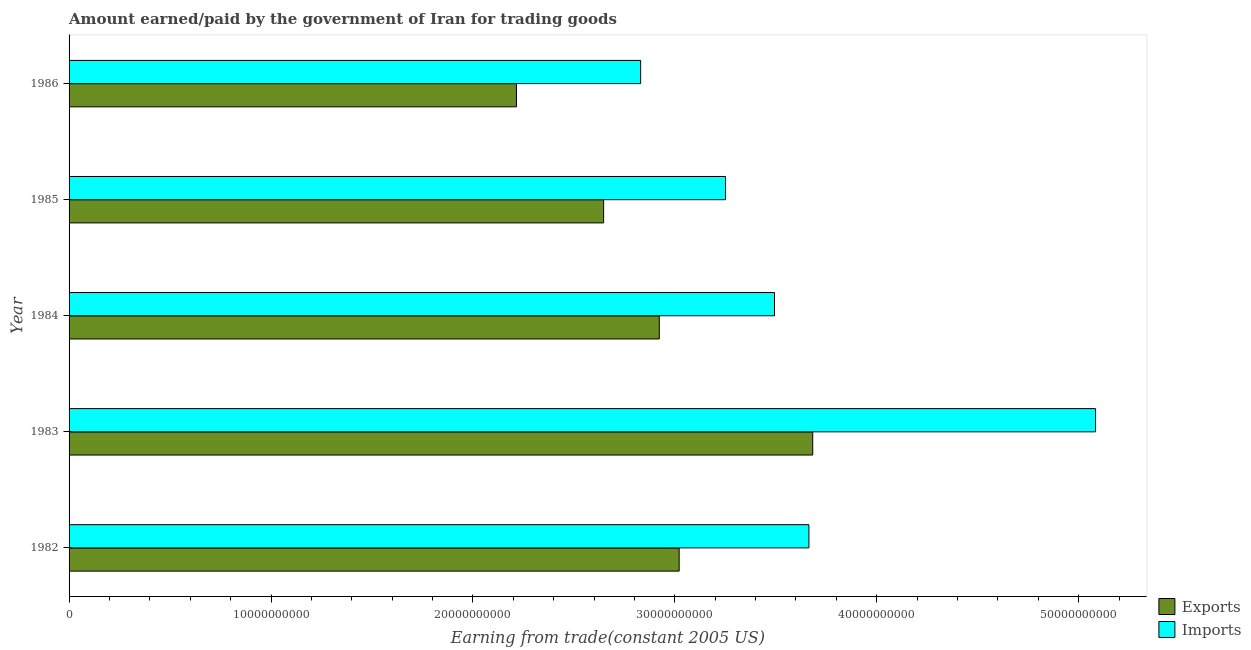How many groups of bars are there?
Make the answer very short. 5. Are the number of bars on each tick of the Y-axis equal?
Ensure brevity in your answer.  Yes. How many bars are there on the 5th tick from the top?
Ensure brevity in your answer.  2. What is the label of the 1st group of bars from the top?
Provide a short and direct response. 1986. In how many cases, is the number of bars for a given year not equal to the number of legend labels?
Provide a short and direct response. 0. What is the amount earned from exports in 1986?
Provide a short and direct response. 2.22e+1. Across all years, what is the maximum amount paid for imports?
Your answer should be compact. 5.08e+1. Across all years, what is the minimum amount paid for imports?
Give a very brief answer. 2.83e+1. In which year was the amount paid for imports minimum?
Provide a succinct answer. 1986. What is the total amount paid for imports in the graph?
Make the answer very short. 1.83e+11. What is the difference between the amount earned from exports in 1983 and that in 1984?
Make the answer very short. 7.60e+09. What is the difference between the amount earned from exports in 1986 and the amount paid for imports in 1982?
Your answer should be compact. -1.45e+1. What is the average amount paid for imports per year?
Give a very brief answer. 3.66e+1. In the year 1982, what is the difference between the amount paid for imports and amount earned from exports?
Your answer should be compact. 6.42e+09. What is the ratio of the amount earned from exports in 1983 to that in 1986?
Your answer should be compact. 1.66. Is the difference between the amount paid for imports in 1984 and 1986 greater than the difference between the amount earned from exports in 1984 and 1986?
Offer a very short reply. No. What is the difference between the highest and the second highest amount paid for imports?
Make the answer very short. 1.42e+1. What is the difference between the highest and the lowest amount earned from exports?
Offer a very short reply. 1.47e+1. In how many years, is the amount paid for imports greater than the average amount paid for imports taken over all years?
Provide a succinct answer. 1. What does the 2nd bar from the top in 1986 represents?
Provide a succinct answer. Exports. What does the 2nd bar from the bottom in 1985 represents?
Provide a succinct answer. Imports. Are all the bars in the graph horizontal?
Your answer should be compact. Yes. How many years are there in the graph?
Provide a short and direct response. 5. What is the difference between two consecutive major ticks on the X-axis?
Your answer should be very brief. 1.00e+1. Are the values on the major ticks of X-axis written in scientific E-notation?
Ensure brevity in your answer.  No. Does the graph contain any zero values?
Give a very brief answer. No. Does the graph contain grids?
Offer a terse response. No. What is the title of the graph?
Your answer should be compact. Amount earned/paid by the government of Iran for trading goods. Does "Public funds" appear as one of the legend labels in the graph?
Ensure brevity in your answer.  No. What is the label or title of the X-axis?
Your answer should be compact. Earning from trade(constant 2005 US). What is the label or title of the Y-axis?
Provide a succinct answer. Year. What is the Earning from trade(constant 2005 US) in Exports in 1982?
Your response must be concise. 3.02e+1. What is the Earning from trade(constant 2005 US) in Imports in 1982?
Your answer should be very brief. 3.66e+1. What is the Earning from trade(constant 2005 US) of Exports in 1983?
Provide a short and direct response. 3.68e+1. What is the Earning from trade(constant 2005 US) of Imports in 1983?
Provide a succinct answer. 5.08e+1. What is the Earning from trade(constant 2005 US) of Exports in 1984?
Provide a succinct answer. 2.92e+1. What is the Earning from trade(constant 2005 US) in Imports in 1984?
Give a very brief answer. 3.49e+1. What is the Earning from trade(constant 2005 US) in Exports in 1985?
Your answer should be compact. 2.65e+1. What is the Earning from trade(constant 2005 US) of Imports in 1985?
Keep it short and to the point. 3.25e+1. What is the Earning from trade(constant 2005 US) of Exports in 1986?
Your answer should be very brief. 2.22e+1. What is the Earning from trade(constant 2005 US) in Imports in 1986?
Your answer should be compact. 2.83e+1. Across all years, what is the maximum Earning from trade(constant 2005 US) of Exports?
Your answer should be compact. 3.68e+1. Across all years, what is the maximum Earning from trade(constant 2005 US) of Imports?
Your response must be concise. 5.08e+1. Across all years, what is the minimum Earning from trade(constant 2005 US) in Exports?
Your response must be concise. 2.22e+1. Across all years, what is the minimum Earning from trade(constant 2005 US) in Imports?
Your answer should be compact. 2.83e+1. What is the total Earning from trade(constant 2005 US) in Exports in the graph?
Make the answer very short. 1.45e+11. What is the total Earning from trade(constant 2005 US) of Imports in the graph?
Make the answer very short. 1.83e+11. What is the difference between the Earning from trade(constant 2005 US) of Exports in 1982 and that in 1983?
Provide a short and direct response. -6.61e+09. What is the difference between the Earning from trade(constant 2005 US) in Imports in 1982 and that in 1983?
Give a very brief answer. -1.42e+1. What is the difference between the Earning from trade(constant 2005 US) of Exports in 1982 and that in 1984?
Your answer should be compact. 9.86e+08. What is the difference between the Earning from trade(constant 2005 US) in Imports in 1982 and that in 1984?
Your answer should be compact. 1.70e+09. What is the difference between the Earning from trade(constant 2005 US) of Exports in 1982 and that in 1985?
Give a very brief answer. 3.74e+09. What is the difference between the Earning from trade(constant 2005 US) in Imports in 1982 and that in 1985?
Keep it short and to the point. 4.13e+09. What is the difference between the Earning from trade(constant 2005 US) of Exports in 1982 and that in 1986?
Ensure brevity in your answer.  8.06e+09. What is the difference between the Earning from trade(constant 2005 US) in Imports in 1982 and that in 1986?
Your answer should be compact. 8.33e+09. What is the difference between the Earning from trade(constant 2005 US) in Exports in 1983 and that in 1984?
Offer a very short reply. 7.60e+09. What is the difference between the Earning from trade(constant 2005 US) in Imports in 1983 and that in 1984?
Your response must be concise. 1.59e+1. What is the difference between the Earning from trade(constant 2005 US) in Exports in 1983 and that in 1985?
Make the answer very short. 1.04e+1. What is the difference between the Earning from trade(constant 2005 US) of Imports in 1983 and that in 1985?
Your answer should be very brief. 1.83e+1. What is the difference between the Earning from trade(constant 2005 US) of Exports in 1983 and that in 1986?
Your response must be concise. 1.47e+1. What is the difference between the Earning from trade(constant 2005 US) in Imports in 1983 and that in 1986?
Offer a very short reply. 2.25e+1. What is the difference between the Earning from trade(constant 2005 US) in Exports in 1984 and that in 1985?
Offer a terse response. 2.76e+09. What is the difference between the Earning from trade(constant 2005 US) of Imports in 1984 and that in 1985?
Ensure brevity in your answer.  2.42e+09. What is the difference between the Earning from trade(constant 2005 US) of Exports in 1984 and that in 1986?
Offer a very short reply. 7.07e+09. What is the difference between the Earning from trade(constant 2005 US) of Imports in 1984 and that in 1986?
Provide a short and direct response. 6.63e+09. What is the difference between the Earning from trade(constant 2005 US) in Exports in 1985 and that in 1986?
Make the answer very short. 4.32e+09. What is the difference between the Earning from trade(constant 2005 US) in Imports in 1985 and that in 1986?
Make the answer very short. 4.20e+09. What is the difference between the Earning from trade(constant 2005 US) of Exports in 1982 and the Earning from trade(constant 2005 US) of Imports in 1983?
Give a very brief answer. -2.06e+1. What is the difference between the Earning from trade(constant 2005 US) in Exports in 1982 and the Earning from trade(constant 2005 US) in Imports in 1984?
Offer a very short reply. -4.72e+09. What is the difference between the Earning from trade(constant 2005 US) in Exports in 1982 and the Earning from trade(constant 2005 US) in Imports in 1985?
Offer a very short reply. -2.30e+09. What is the difference between the Earning from trade(constant 2005 US) in Exports in 1982 and the Earning from trade(constant 2005 US) in Imports in 1986?
Make the answer very short. 1.91e+09. What is the difference between the Earning from trade(constant 2005 US) in Exports in 1983 and the Earning from trade(constant 2005 US) in Imports in 1984?
Ensure brevity in your answer.  1.89e+09. What is the difference between the Earning from trade(constant 2005 US) in Exports in 1983 and the Earning from trade(constant 2005 US) in Imports in 1985?
Offer a very short reply. 4.32e+09. What is the difference between the Earning from trade(constant 2005 US) in Exports in 1983 and the Earning from trade(constant 2005 US) in Imports in 1986?
Offer a very short reply. 8.52e+09. What is the difference between the Earning from trade(constant 2005 US) of Exports in 1984 and the Earning from trade(constant 2005 US) of Imports in 1985?
Your answer should be compact. -3.28e+09. What is the difference between the Earning from trade(constant 2005 US) of Exports in 1984 and the Earning from trade(constant 2005 US) of Imports in 1986?
Provide a short and direct response. 9.23e+08. What is the difference between the Earning from trade(constant 2005 US) in Exports in 1985 and the Earning from trade(constant 2005 US) in Imports in 1986?
Your response must be concise. -1.83e+09. What is the average Earning from trade(constant 2005 US) of Exports per year?
Your answer should be very brief. 2.90e+1. What is the average Earning from trade(constant 2005 US) of Imports per year?
Make the answer very short. 3.66e+1. In the year 1982, what is the difference between the Earning from trade(constant 2005 US) in Exports and Earning from trade(constant 2005 US) in Imports?
Offer a very short reply. -6.42e+09. In the year 1983, what is the difference between the Earning from trade(constant 2005 US) of Exports and Earning from trade(constant 2005 US) of Imports?
Provide a succinct answer. -1.40e+1. In the year 1984, what is the difference between the Earning from trade(constant 2005 US) in Exports and Earning from trade(constant 2005 US) in Imports?
Keep it short and to the point. -5.71e+09. In the year 1985, what is the difference between the Earning from trade(constant 2005 US) of Exports and Earning from trade(constant 2005 US) of Imports?
Give a very brief answer. -6.04e+09. In the year 1986, what is the difference between the Earning from trade(constant 2005 US) in Exports and Earning from trade(constant 2005 US) in Imports?
Provide a short and direct response. -6.15e+09. What is the ratio of the Earning from trade(constant 2005 US) in Exports in 1982 to that in 1983?
Your answer should be compact. 0.82. What is the ratio of the Earning from trade(constant 2005 US) in Imports in 1982 to that in 1983?
Provide a short and direct response. 0.72. What is the ratio of the Earning from trade(constant 2005 US) in Exports in 1982 to that in 1984?
Give a very brief answer. 1.03. What is the ratio of the Earning from trade(constant 2005 US) of Imports in 1982 to that in 1984?
Your response must be concise. 1.05. What is the ratio of the Earning from trade(constant 2005 US) of Exports in 1982 to that in 1985?
Give a very brief answer. 1.14. What is the ratio of the Earning from trade(constant 2005 US) in Imports in 1982 to that in 1985?
Offer a terse response. 1.13. What is the ratio of the Earning from trade(constant 2005 US) in Exports in 1982 to that in 1986?
Keep it short and to the point. 1.36. What is the ratio of the Earning from trade(constant 2005 US) in Imports in 1982 to that in 1986?
Provide a short and direct response. 1.29. What is the ratio of the Earning from trade(constant 2005 US) in Exports in 1983 to that in 1984?
Provide a short and direct response. 1.26. What is the ratio of the Earning from trade(constant 2005 US) in Imports in 1983 to that in 1984?
Provide a short and direct response. 1.46. What is the ratio of the Earning from trade(constant 2005 US) of Exports in 1983 to that in 1985?
Provide a succinct answer. 1.39. What is the ratio of the Earning from trade(constant 2005 US) of Imports in 1983 to that in 1985?
Your answer should be very brief. 1.56. What is the ratio of the Earning from trade(constant 2005 US) of Exports in 1983 to that in 1986?
Keep it short and to the point. 1.66. What is the ratio of the Earning from trade(constant 2005 US) of Imports in 1983 to that in 1986?
Keep it short and to the point. 1.8. What is the ratio of the Earning from trade(constant 2005 US) in Exports in 1984 to that in 1985?
Provide a short and direct response. 1.1. What is the ratio of the Earning from trade(constant 2005 US) in Imports in 1984 to that in 1985?
Your response must be concise. 1.07. What is the ratio of the Earning from trade(constant 2005 US) in Exports in 1984 to that in 1986?
Offer a terse response. 1.32. What is the ratio of the Earning from trade(constant 2005 US) of Imports in 1984 to that in 1986?
Provide a succinct answer. 1.23. What is the ratio of the Earning from trade(constant 2005 US) of Exports in 1985 to that in 1986?
Your response must be concise. 1.19. What is the ratio of the Earning from trade(constant 2005 US) in Imports in 1985 to that in 1986?
Ensure brevity in your answer.  1.15. What is the difference between the highest and the second highest Earning from trade(constant 2005 US) of Exports?
Your answer should be very brief. 6.61e+09. What is the difference between the highest and the second highest Earning from trade(constant 2005 US) of Imports?
Your answer should be very brief. 1.42e+1. What is the difference between the highest and the lowest Earning from trade(constant 2005 US) in Exports?
Your response must be concise. 1.47e+1. What is the difference between the highest and the lowest Earning from trade(constant 2005 US) in Imports?
Your answer should be compact. 2.25e+1. 